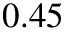<formula> <loc_0><loc_0><loc_500><loc_500>0 . 4 5</formula> 